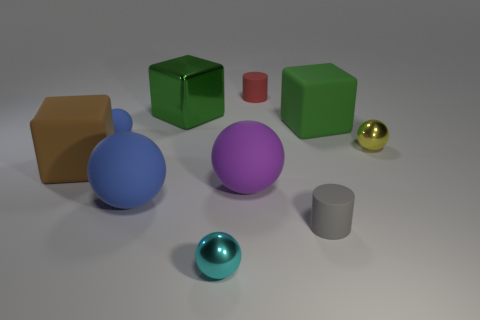What materials are depicted in the objects shown in the image? The image showcases objects with various materials. The big brown and tiny blue balls have a glossy finish suggesting a smooth plastic or polished metal. The green cube and purple ball have a matte finish, which implies they might be made of a dull plastic or possibly painted wood. The yellow cube shows a texture that could represent cardboard, and the small red cylinder seems to have a satin finish, indicating a different type of plastic or coated metal. Lastly, the gray objects, a cylinder, and a ball bearing, might be made of steel or aluminum due to their metallic luster. 